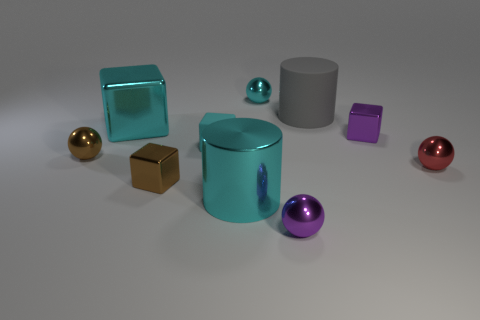What number of objects are either purple shiny things or small metallic spheres that are in front of the cyan shiny cylinder?
Your answer should be very brief. 2. What is the size of the metal sphere that is the same color as the tiny matte object?
Provide a succinct answer. Small. The purple thing right of the rubber cylinder has what shape?
Make the answer very short. Cube. Does the big object left of the matte block have the same color as the tiny matte thing?
Ensure brevity in your answer.  Yes. There is another cube that is the same color as the large cube; what is its material?
Provide a succinct answer. Rubber. There is a block that is in front of the cyan rubber cube; is it the same size as the purple cube?
Ensure brevity in your answer.  Yes. Are there any big things of the same color as the tiny matte block?
Keep it short and to the point. Yes. There is a cyan object in front of the tiny brown shiny block; is there a shiny object on the left side of it?
Offer a very short reply. Yes. Are there any brown objects that have the same material as the big cyan block?
Your answer should be compact. Yes. What material is the small cyan object that is to the left of the big cyan thing in front of the small cyan cube?
Offer a terse response. Rubber. 